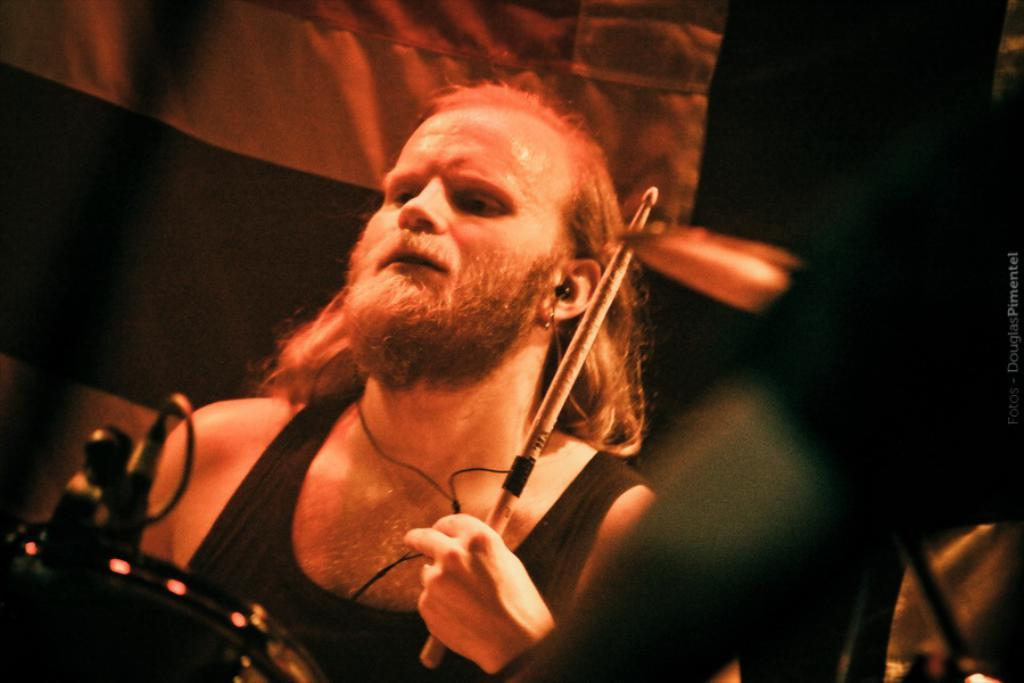What is the main subject of the image? The main subject of the image is a man. What is the man holding in his hand? The man is holding a stick in his hand. What is the man wearing on his ears? The man is wearing earphones. What can be seen in the image besides the man? There is a white banner and some objects in the image. How would you describe the background of the image? The background of the image is dark. What color is the egg that the man is holding in the image? There is no egg present in the image; the man is holding a stick. What hobbies does the man have, as depicted in the image? The image does not provide information about the man's hobbies. 